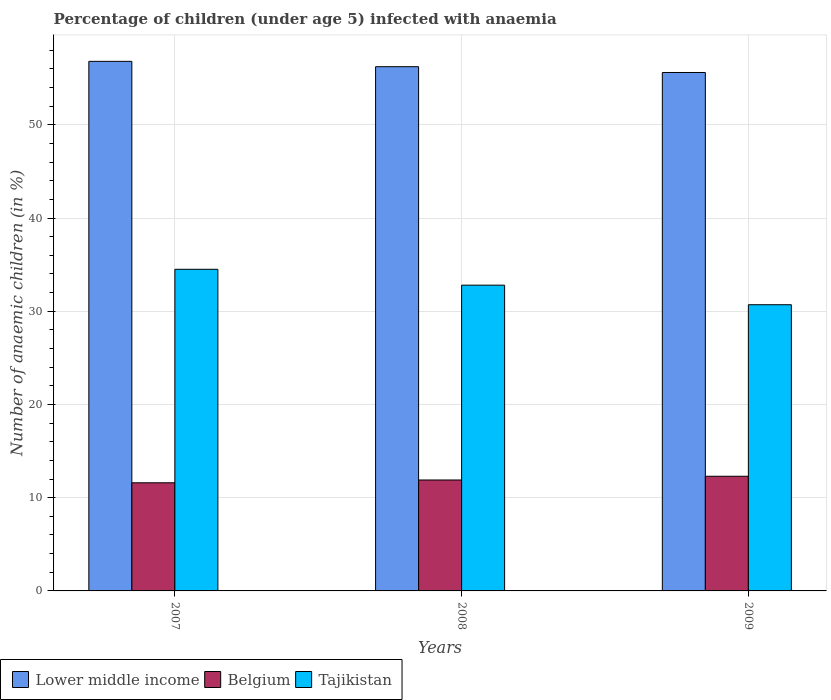How many different coloured bars are there?
Make the answer very short. 3. Are the number of bars per tick equal to the number of legend labels?
Provide a succinct answer. Yes. What is the label of the 1st group of bars from the left?
Ensure brevity in your answer.  2007. In how many cases, is the number of bars for a given year not equal to the number of legend labels?
Your answer should be compact. 0. What is the percentage of children infected with anaemia in in Lower middle income in 2008?
Provide a short and direct response. 56.24. Across all years, what is the maximum percentage of children infected with anaemia in in Belgium?
Your answer should be very brief. 12.3. Across all years, what is the minimum percentage of children infected with anaemia in in Lower middle income?
Your answer should be compact. 55.61. In which year was the percentage of children infected with anaemia in in Tajikistan minimum?
Make the answer very short. 2009. What is the total percentage of children infected with anaemia in in Belgium in the graph?
Ensure brevity in your answer.  35.8. What is the difference between the percentage of children infected with anaemia in in Tajikistan in 2007 and that in 2008?
Keep it short and to the point. 1.7. What is the difference between the percentage of children infected with anaemia in in Tajikistan in 2007 and the percentage of children infected with anaemia in in Belgium in 2009?
Keep it short and to the point. 22.2. What is the average percentage of children infected with anaemia in in Belgium per year?
Provide a short and direct response. 11.93. In the year 2009, what is the difference between the percentage of children infected with anaemia in in Belgium and percentage of children infected with anaemia in in Tajikistan?
Provide a succinct answer. -18.4. In how many years, is the percentage of children infected with anaemia in in Lower middle income greater than 28 %?
Offer a terse response. 3. What is the ratio of the percentage of children infected with anaemia in in Lower middle income in 2007 to that in 2009?
Your response must be concise. 1.02. Is the percentage of children infected with anaemia in in Tajikistan in 2007 less than that in 2008?
Offer a terse response. No. Is the difference between the percentage of children infected with anaemia in in Belgium in 2008 and 2009 greater than the difference between the percentage of children infected with anaemia in in Tajikistan in 2008 and 2009?
Offer a terse response. No. What is the difference between the highest and the second highest percentage of children infected with anaemia in in Lower middle income?
Offer a terse response. 0.57. What is the difference between the highest and the lowest percentage of children infected with anaemia in in Belgium?
Offer a very short reply. 0.7. In how many years, is the percentage of children infected with anaemia in in Lower middle income greater than the average percentage of children infected with anaemia in in Lower middle income taken over all years?
Offer a very short reply. 2. What does the 3rd bar from the left in 2009 represents?
Offer a very short reply. Tajikistan. What does the 3rd bar from the right in 2008 represents?
Make the answer very short. Lower middle income. Is it the case that in every year, the sum of the percentage of children infected with anaemia in in Belgium and percentage of children infected with anaemia in in Lower middle income is greater than the percentage of children infected with anaemia in in Tajikistan?
Make the answer very short. Yes. Does the graph contain grids?
Your answer should be compact. Yes. How many legend labels are there?
Ensure brevity in your answer.  3. What is the title of the graph?
Provide a short and direct response. Percentage of children (under age 5) infected with anaemia. Does "Tuvalu" appear as one of the legend labels in the graph?
Your response must be concise. No. What is the label or title of the Y-axis?
Your answer should be very brief. Number of anaemic children (in %). What is the Number of anaemic children (in %) of Lower middle income in 2007?
Provide a short and direct response. 56.81. What is the Number of anaemic children (in %) of Belgium in 2007?
Your response must be concise. 11.6. What is the Number of anaemic children (in %) of Tajikistan in 2007?
Your answer should be compact. 34.5. What is the Number of anaemic children (in %) in Lower middle income in 2008?
Your answer should be very brief. 56.24. What is the Number of anaemic children (in %) in Belgium in 2008?
Provide a succinct answer. 11.9. What is the Number of anaemic children (in %) in Tajikistan in 2008?
Make the answer very short. 32.8. What is the Number of anaemic children (in %) of Lower middle income in 2009?
Your answer should be very brief. 55.61. What is the Number of anaemic children (in %) in Belgium in 2009?
Your answer should be compact. 12.3. What is the Number of anaemic children (in %) in Tajikistan in 2009?
Offer a very short reply. 30.7. Across all years, what is the maximum Number of anaemic children (in %) in Lower middle income?
Offer a very short reply. 56.81. Across all years, what is the maximum Number of anaemic children (in %) of Belgium?
Your response must be concise. 12.3. Across all years, what is the maximum Number of anaemic children (in %) in Tajikistan?
Offer a very short reply. 34.5. Across all years, what is the minimum Number of anaemic children (in %) in Lower middle income?
Offer a very short reply. 55.61. Across all years, what is the minimum Number of anaemic children (in %) of Belgium?
Ensure brevity in your answer.  11.6. Across all years, what is the minimum Number of anaemic children (in %) of Tajikistan?
Make the answer very short. 30.7. What is the total Number of anaemic children (in %) in Lower middle income in the graph?
Provide a succinct answer. 168.66. What is the total Number of anaemic children (in %) of Belgium in the graph?
Offer a terse response. 35.8. What is the difference between the Number of anaemic children (in %) in Lower middle income in 2007 and that in 2008?
Your response must be concise. 0.57. What is the difference between the Number of anaemic children (in %) in Lower middle income in 2007 and that in 2009?
Offer a very short reply. 1.2. What is the difference between the Number of anaemic children (in %) of Belgium in 2007 and that in 2009?
Offer a very short reply. -0.7. What is the difference between the Number of anaemic children (in %) in Tajikistan in 2007 and that in 2009?
Provide a short and direct response. 3.8. What is the difference between the Number of anaemic children (in %) in Lower middle income in 2008 and that in 2009?
Your answer should be very brief. 0.62. What is the difference between the Number of anaemic children (in %) in Tajikistan in 2008 and that in 2009?
Give a very brief answer. 2.1. What is the difference between the Number of anaemic children (in %) in Lower middle income in 2007 and the Number of anaemic children (in %) in Belgium in 2008?
Keep it short and to the point. 44.91. What is the difference between the Number of anaemic children (in %) of Lower middle income in 2007 and the Number of anaemic children (in %) of Tajikistan in 2008?
Offer a terse response. 24.01. What is the difference between the Number of anaemic children (in %) of Belgium in 2007 and the Number of anaemic children (in %) of Tajikistan in 2008?
Offer a terse response. -21.2. What is the difference between the Number of anaemic children (in %) in Lower middle income in 2007 and the Number of anaemic children (in %) in Belgium in 2009?
Your answer should be very brief. 44.51. What is the difference between the Number of anaemic children (in %) of Lower middle income in 2007 and the Number of anaemic children (in %) of Tajikistan in 2009?
Provide a succinct answer. 26.11. What is the difference between the Number of anaemic children (in %) in Belgium in 2007 and the Number of anaemic children (in %) in Tajikistan in 2009?
Keep it short and to the point. -19.1. What is the difference between the Number of anaemic children (in %) in Lower middle income in 2008 and the Number of anaemic children (in %) in Belgium in 2009?
Your answer should be very brief. 43.94. What is the difference between the Number of anaemic children (in %) in Lower middle income in 2008 and the Number of anaemic children (in %) in Tajikistan in 2009?
Offer a terse response. 25.54. What is the difference between the Number of anaemic children (in %) of Belgium in 2008 and the Number of anaemic children (in %) of Tajikistan in 2009?
Provide a short and direct response. -18.8. What is the average Number of anaemic children (in %) in Lower middle income per year?
Keep it short and to the point. 56.22. What is the average Number of anaemic children (in %) of Belgium per year?
Offer a very short reply. 11.93. What is the average Number of anaemic children (in %) of Tajikistan per year?
Make the answer very short. 32.67. In the year 2007, what is the difference between the Number of anaemic children (in %) in Lower middle income and Number of anaemic children (in %) in Belgium?
Give a very brief answer. 45.21. In the year 2007, what is the difference between the Number of anaemic children (in %) of Lower middle income and Number of anaemic children (in %) of Tajikistan?
Your response must be concise. 22.31. In the year 2007, what is the difference between the Number of anaemic children (in %) in Belgium and Number of anaemic children (in %) in Tajikistan?
Provide a succinct answer. -22.9. In the year 2008, what is the difference between the Number of anaemic children (in %) of Lower middle income and Number of anaemic children (in %) of Belgium?
Your answer should be compact. 44.34. In the year 2008, what is the difference between the Number of anaemic children (in %) of Lower middle income and Number of anaemic children (in %) of Tajikistan?
Make the answer very short. 23.44. In the year 2008, what is the difference between the Number of anaemic children (in %) in Belgium and Number of anaemic children (in %) in Tajikistan?
Provide a succinct answer. -20.9. In the year 2009, what is the difference between the Number of anaemic children (in %) in Lower middle income and Number of anaemic children (in %) in Belgium?
Your answer should be very brief. 43.31. In the year 2009, what is the difference between the Number of anaemic children (in %) of Lower middle income and Number of anaemic children (in %) of Tajikistan?
Make the answer very short. 24.91. In the year 2009, what is the difference between the Number of anaemic children (in %) in Belgium and Number of anaemic children (in %) in Tajikistan?
Your answer should be very brief. -18.4. What is the ratio of the Number of anaemic children (in %) of Lower middle income in 2007 to that in 2008?
Your answer should be very brief. 1.01. What is the ratio of the Number of anaemic children (in %) of Belgium in 2007 to that in 2008?
Provide a short and direct response. 0.97. What is the ratio of the Number of anaemic children (in %) of Tajikistan in 2007 to that in 2008?
Provide a succinct answer. 1.05. What is the ratio of the Number of anaemic children (in %) of Lower middle income in 2007 to that in 2009?
Offer a very short reply. 1.02. What is the ratio of the Number of anaemic children (in %) of Belgium in 2007 to that in 2009?
Give a very brief answer. 0.94. What is the ratio of the Number of anaemic children (in %) in Tajikistan in 2007 to that in 2009?
Give a very brief answer. 1.12. What is the ratio of the Number of anaemic children (in %) in Lower middle income in 2008 to that in 2009?
Provide a succinct answer. 1.01. What is the ratio of the Number of anaemic children (in %) in Belgium in 2008 to that in 2009?
Your answer should be very brief. 0.97. What is the ratio of the Number of anaemic children (in %) in Tajikistan in 2008 to that in 2009?
Offer a terse response. 1.07. What is the difference between the highest and the second highest Number of anaemic children (in %) of Lower middle income?
Offer a terse response. 0.57. What is the difference between the highest and the second highest Number of anaemic children (in %) in Tajikistan?
Offer a very short reply. 1.7. What is the difference between the highest and the lowest Number of anaemic children (in %) in Lower middle income?
Your answer should be compact. 1.2. What is the difference between the highest and the lowest Number of anaemic children (in %) in Belgium?
Give a very brief answer. 0.7. What is the difference between the highest and the lowest Number of anaemic children (in %) of Tajikistan?
Make the answer very short. 3.8. 